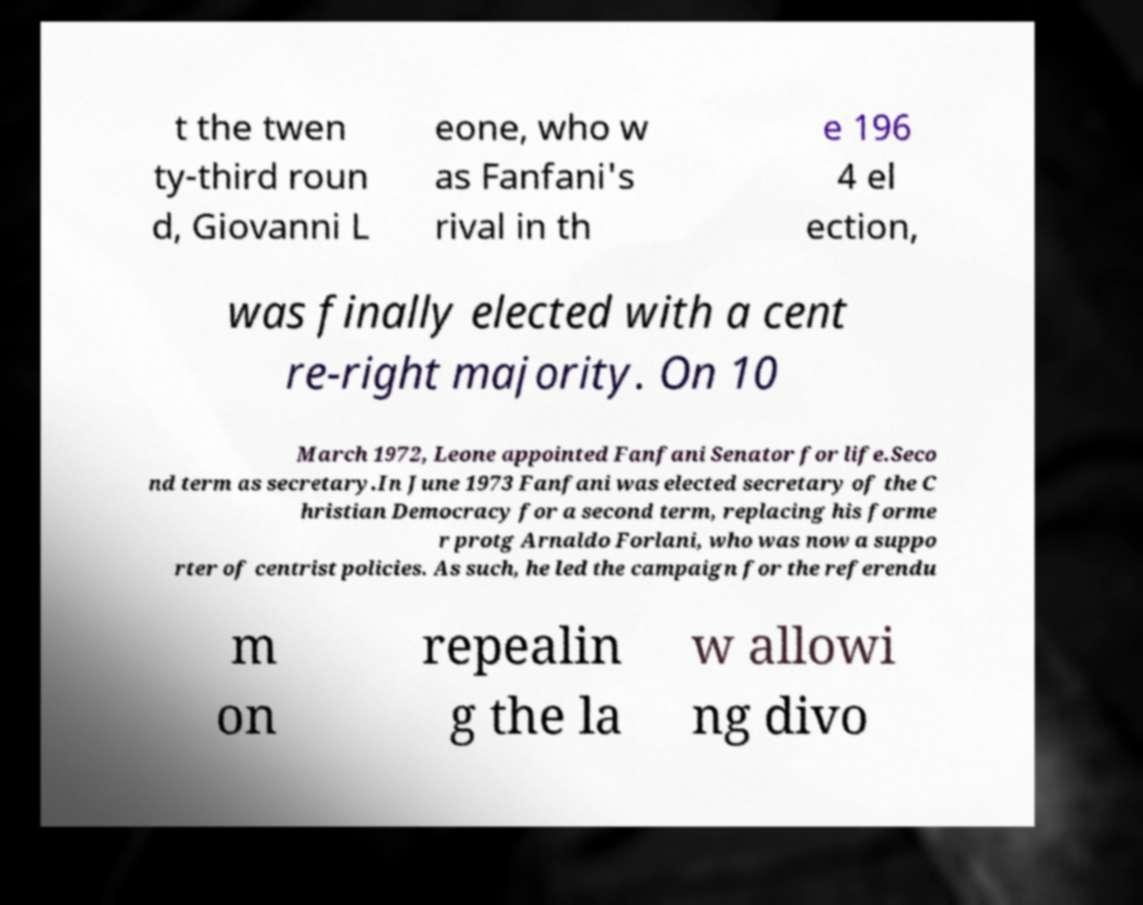Please identify and transcribe the text found in this image. t the twen ty-third roun d, Giovanni L eone, who w as Fanfani's rival in th e 196 4 el ection, was finally elected with a cent re-right majority. On 10 March 1972, Leone appointed Fanfani Senator for life.Seco nd term as secretary.In June 1973 Fanfani was elected secretary of the C hristian Democracy for a second term, replacing his forme r protg Arnaldo Forlani, who was now a suppo rter of centrist policies. As such, he led the campaign for the referendu m on repealin g the la w allowi ng divo 